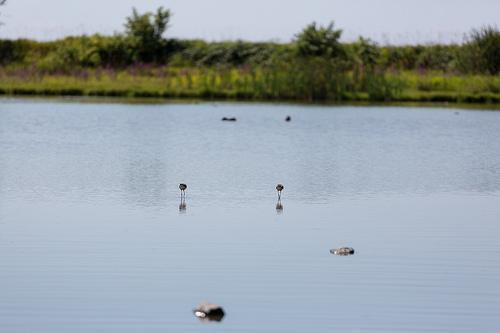How many animals?
Give a very brief answer. 6. 